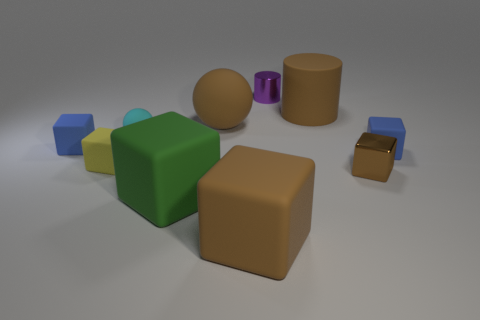How many tiny objects are either matte spheres or purple shiny balls?
Your response must be concise. 1. There is a large matte object behind the matte ball that is on the right side of the tiny cyan matte thing; is there a large object that is in front of it?
Give a very brief answer. Yes. Are there any other things that have the same size as the yellow object?
Provide a succinct answer. Yes. What material is the other cube that is the same size as the green matte cube?
Offer a very short reply. Rubber. Do the purple metal thing and the rubber thing on the right side of the big brown rubber cylinder have the same size?
Offer a very short reply. Yes. How many metallic objects are either green blocks or tiny spheres?
Make the answer very short. 0. How many other small shiny things have the same shape as the green object?
Offer a very short reply. 1. There is a tiny cube that is the same color as the big cylinder; what material is it?
Make the answer very short. Metal. There is a shiny thing in front of the cyan sphere; is it the same size as the brown matte object that is in front of the small cyan matte thing?
Your answer should be very brief. No. The small shiny object left of the brown metal block has what shape?
Your answer should be very brief. Cylinder. 